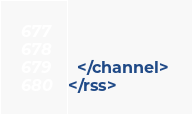<code> <loc_0><loc_0><loc_500><loc_500><_XML_>    
    
  </channel>
</rss></code> 